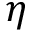<formula> <loc_0><loc_0><loc_500><loc_500>\eta</formula> 